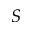<formula> <loc_0><loc_0><loc_500><loc_500>S</formula> 